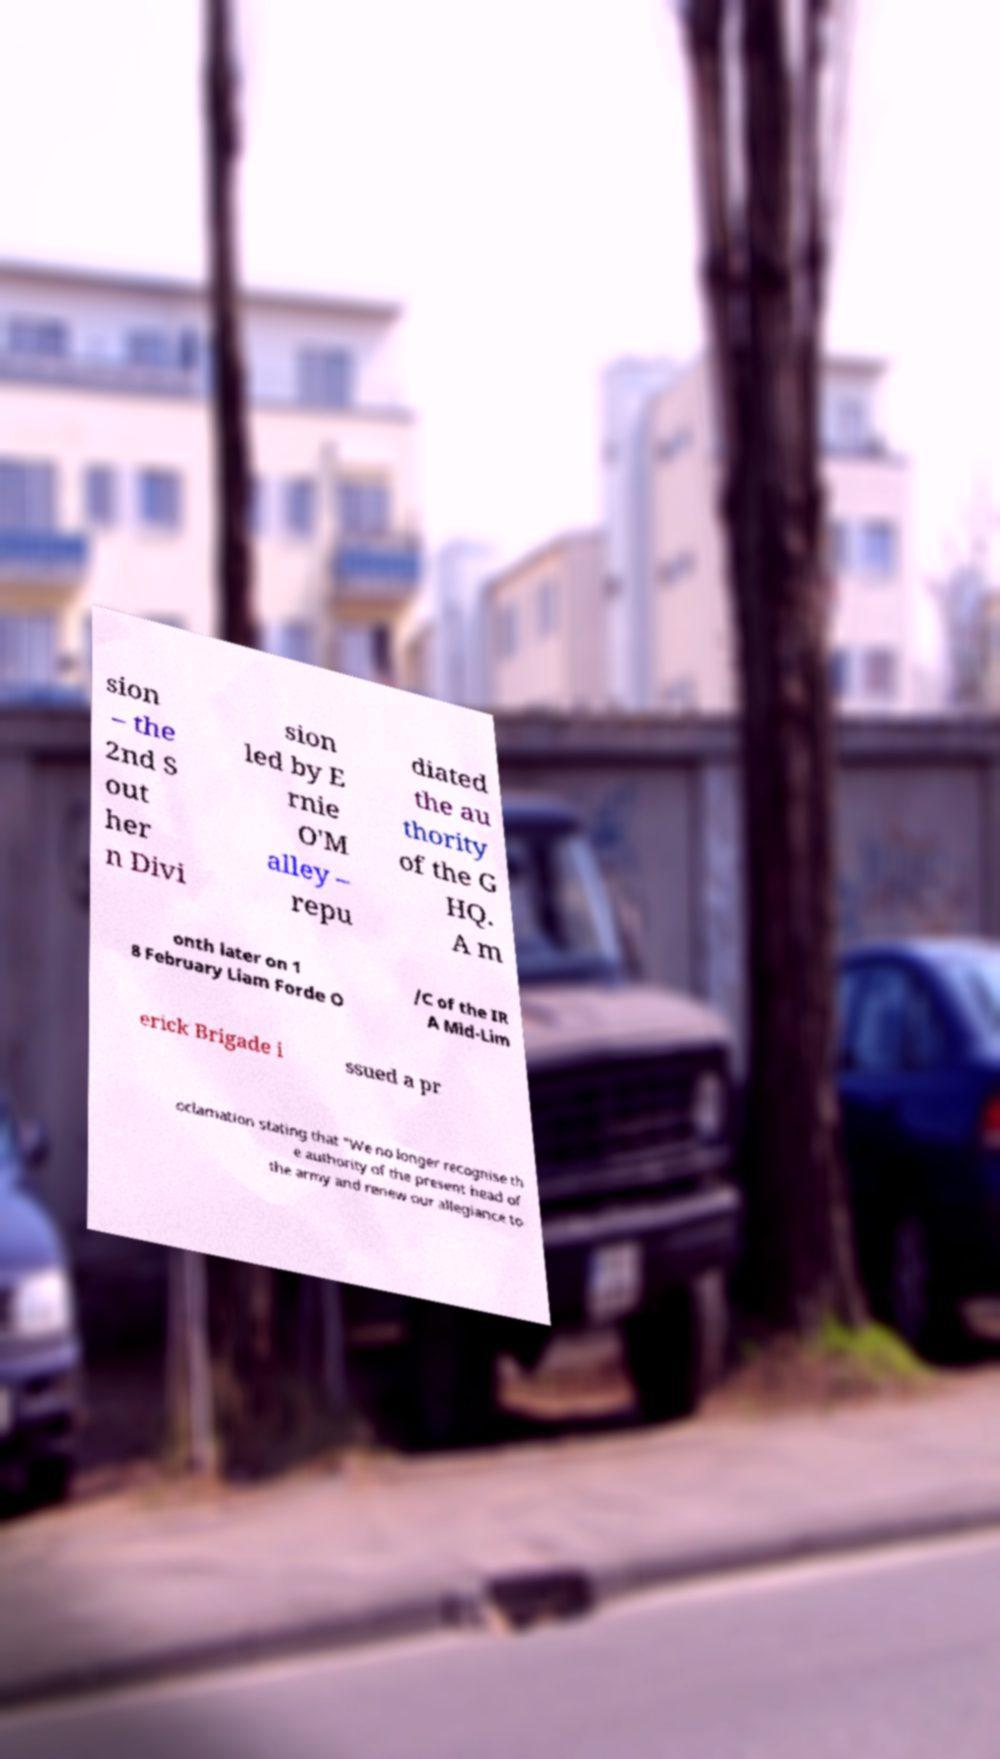What messages or text are displayed in this image? I need them in a readable, typed format. sion – the 2nd S out her n Divi sion led by E rnie O'M alley – repu diated the au thority of the G HQ. A m onth later on 1 8 February Liam Forde O /C of the IR A Mid-Lim erick Brigade i ssued a pr oclamation stating that "We no longer recognise th e authority of the present head of the army and renew our allegiance to 